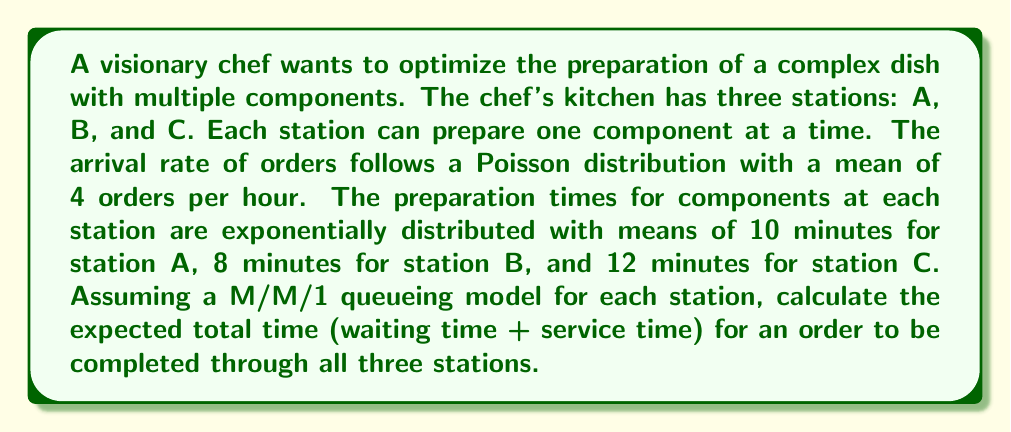Could you help me with this problem? To solve this problem, we'll use queueing theory, specifically the M/M/1 model for each station. We'll follow these steps:

1. Calculate the arrival rate (λ) and service rate (μ) for each station.
2. Determine the utilization factor (ρ) for each station.
3. Calculate the expected total time (W) for each station.
4. Sum up the total times for all stations.

Step 1: Calculate λ and μ
λ = 4 orders/hour = 1/15 orders/minute (for all stations)
μ_A = 1/10 orders/minute
μ_B = 1/8 orders/minute
μ_C = 1/12 orders/minute

Step 2: Determine ρ for each station
ρ = λ/μ
ρ_A = (1/15) / (1/10) = 2/3
ρ_B = (1/15) / (1/8) = 8/15
ρ_C = (1/15) / (1/12) = 4/5

Step 3: Calculate W for each station
For an M/M/1 queue, the expected total time is given by:
$$ W = \frac{1}{\mu - \lambda} $$

W_A = 1 / (1/10 - 1/15) = 30 minutes
W_B = 1 / (1/8 - 1/15) = 24 minutes
W_C = 1 / (1/12 - 1/15) = 60 minutes

Step 4: Sum up the total times
Total expected time = W_A + W_B + W_C
= 30 + 24 + 60 = 114 minutes
Answer: The expected total time for an order to be completed through all three stations is 114 minutes. 